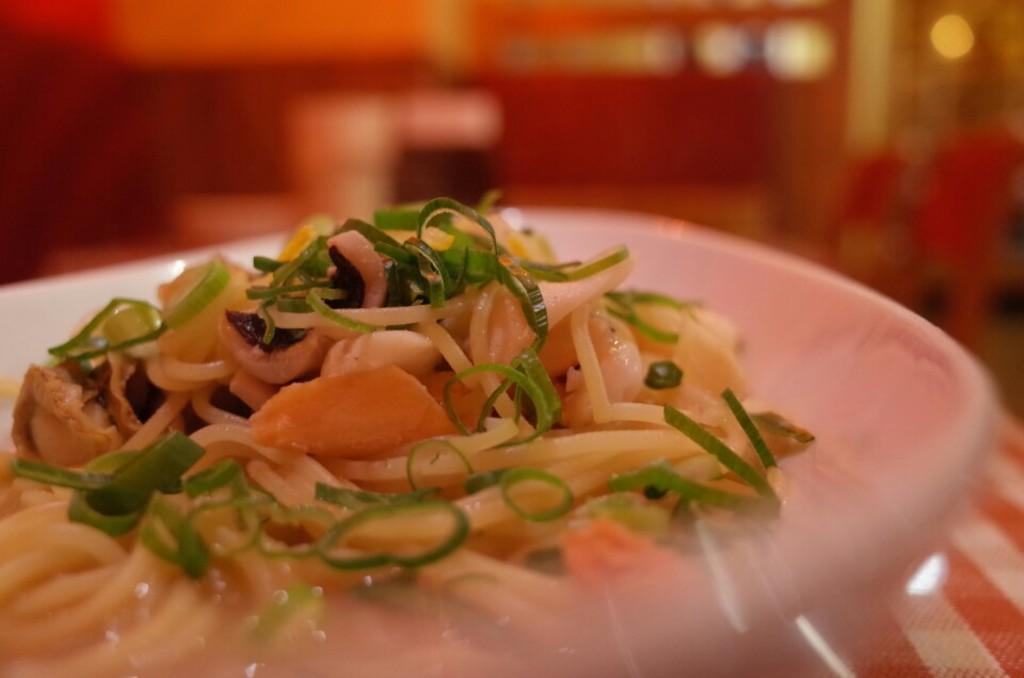What is on the plate in the image? There is food on a plate in the image. What is covering the table in the image? The table is covered with a red and white check cloth. What can be seen in the background of the image? There are chairs visible in the background of the image. How would you describe the quality of the image? The image is blurry. What type of dog is sitting next to the plate in the image? There is no dog present in the image; it only features food on a plate, a table with a red and white check cloth, chairs in the background, and a blurry quality. 